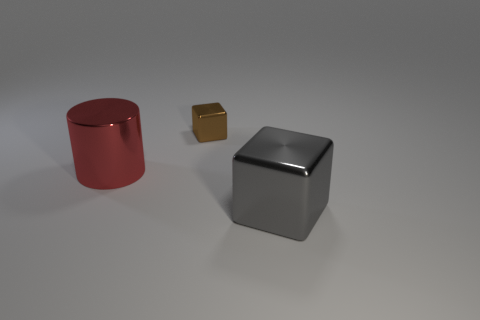Add 1 large red metallic spheres. How many objects exist? 4 Subtract all blocks. How many objects are left? 1 Add 3 rubber things. How many rubber things exist? 3 Subtract 0 green spheres. How many objects are left? 3 Subtract all small gray shiny cylinders. Subtract all large gray shiny objects. How many objects are left? 2 Add 3 small brown metallic blocks. How many small brown metallic blocks are left? 4 